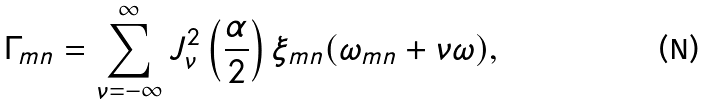<formula> <loc_0><loc_0><loc_500><loc_500>\Gamma _ { m n } = \sum _ { \nu = - \infty } ^ { \infty } J _ { \nu } ^ { 2 } \left ( \frac { \alpha } { 2 } \right ) \xi _ { m n } ( \omega _ { m n } + \nu \omega ) ,</formula> 